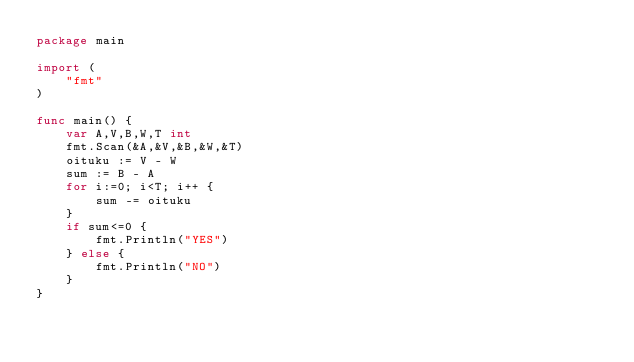<code> <loc_0><loc_0><loc_500><loc_500><_Go_>package main

import (
	"fmt"
)

func main() {
	var A,V,B,W,T int
	fmt.Scan(&A,&V,&B,&W,&T)
	oituku := V - W
	sum := B - A
	for i:=0; i<T; i++ {
		sum -= oituku
	}
	if sum<=0 {
		fmt.Println("YES")
	} else {
		fmt.Println("NO")
	}
}</code> 